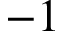Convert formula to latex. <formula><loc_0><loc_0><loc_500><loc_500>- 1</formula> 